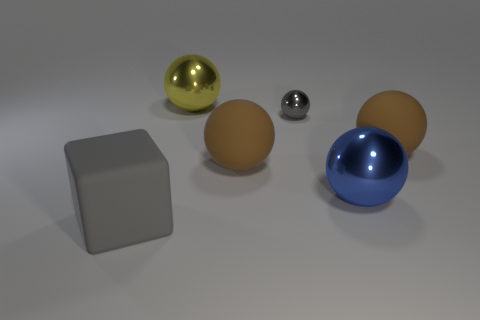What is the color of the big matte object that is left of the large yellow ball?
Keep it short and to the point. Gray. How many rubber objects are large blue balls or small red cylinders?
Your response must be concise. 0. The thing that is the same color as the big matte cube is what shape?
Your answer should be very brief. Sphere. What number of brown objects are the same size as the gray matte block?
Your answer should be very brief. 2. What is the color of the big rubber object that is both to the left of the gray shiny thing and behind the gray rubber thing?
Offer a very short reply. Brown. What number of things are gray rubber blocks or gray shiny things?
Keep it short and to the point. 2. How many small objects are gray spheres or brown balls?
Offer a very short reply. 1. Are there any other things that have the same color as the big matte block?
Make the answer very short. Yes. What is the size of the metallic sphere that is in front of the yellow object and to the left of the blue thing?
Your response must be concise. Small. There is a large cube that is in front of the yellow sphere; is it the same color as the tiny object behind the large blue shiny object?
Provide a succinct answer. Yes. 